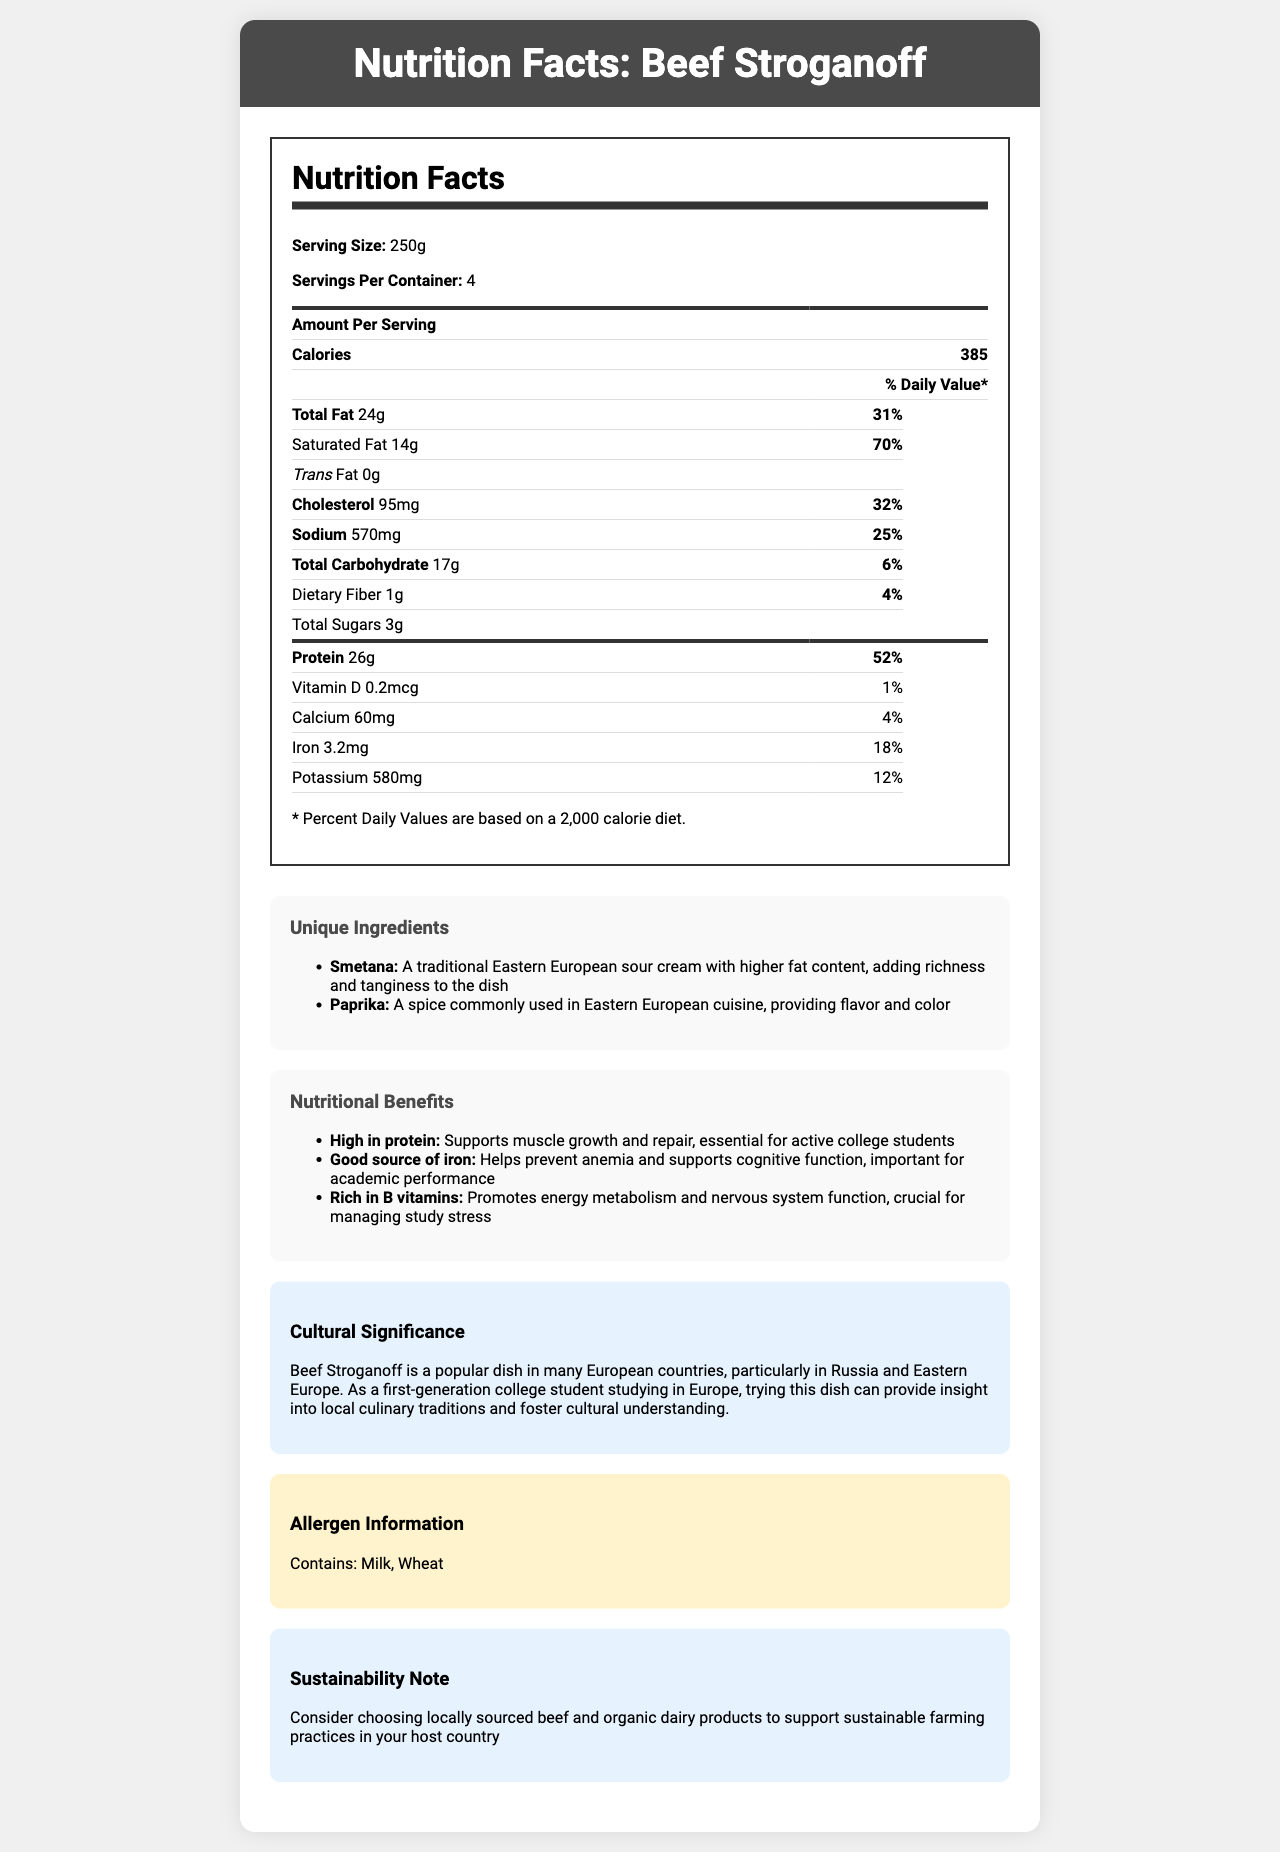what is the serving size? The serving size is explicitly mentioned in the document's nutrition label.
Answer: 250g how many calories are in one serving? The number of calories per serving is clearly listed in the nutrition label.
Answer: 385 calories what is the daily value percentage of saturated fat in one serving? The daily value percentage of saturated fat is given as 70% in the nutrition label.
Answer: 70% how much protein is in one serving? The amount of protein per serving is mentioned as 26g in the nutrition label.
Answer: 26g what are the unique ingredients in Beef Stroganoff? The unique ingredients listed are Smetana and Paprika.
Answer: Smetana and Paprika which vitamin has the lowest daily value percentage in one serving? A. Vitamin D B. Calcium C. Iron D. Potassium The daily value of Vitamin D is 1%, which is the lowest among the listed vitamins and minerals.
Answer: A. Vitamin D what is one of the nutritional benefits of Beef Stroganoff? A. High in carbohydrates B. Good source of iron C. Low in sodium One of the nutritional benefits listed is that it is a good source of iron, which helps prevent anemia and supports cognitive function.
Answer: B. Good source of iron does this dish contain wheat? The allergen information section notes that the dish contains wheat.
Answer: Yes what is the cultural significance of Beef Stroganoff? The cultural significance is explicitly stated in the document, highlighting its popularity in European countries, especially Russia and Eastern Europe, and its importance for cultural understanding.
Answer: Beef Stroganoff is a popular dish in many European countries, particularly in Russia and Eastern Europe. As a first-generation college student studying in Europe, trying this dish can provide insight into local culinary traditions and foster cultural understanding. is it possible to determine where the beef used in Beef Stroganoff is sourced from based on this document? The document does not provide details on the source of the beef used in the dish.
Answer: Not enough information how does the dish support sustainability practices? The sustainability note advises choosing locally sourced beef and organic dairy products to support sustainable farming practices.
Answer: Choosing locally sourced beef and organic dairy products to support sustainable farming practices in your host country what is the total fat content in one serving of Beef Stroganoff? The total fat content per serving is clearly stated as 24g in the nutrition label.
Answer: 24g what is the purpose of Smetana in Beef Stroganoff? Smetana is described as a traditional Eastern European sour cream with higher fat content, adding richness and tanginess to the dish.
Answer: Adds richness and tanginess to the dish based on the nutrition facts, is Beef Stroganoff high in protein? The document states that one of the nutritional benefits of Beef Stroganoff is that it is high in protein, which supports muscle growth and repair.
Answer: Yes what is the overall purpose of this document? The document aims to inform the reader about the nutritional content, cultural importance, and sustainability practices related to Beef Stroganoff, while also highlighting its health benefits and unique ingredients.
Answer: The document provides detailed nutritional information about Beef Stroganoff, including serving size, calorie count, amounts of various nutrients, and daily value percentages. It also highlights unique ingredients, nutritional benefits, cultural significance, allergen information, and sustainability practices. 